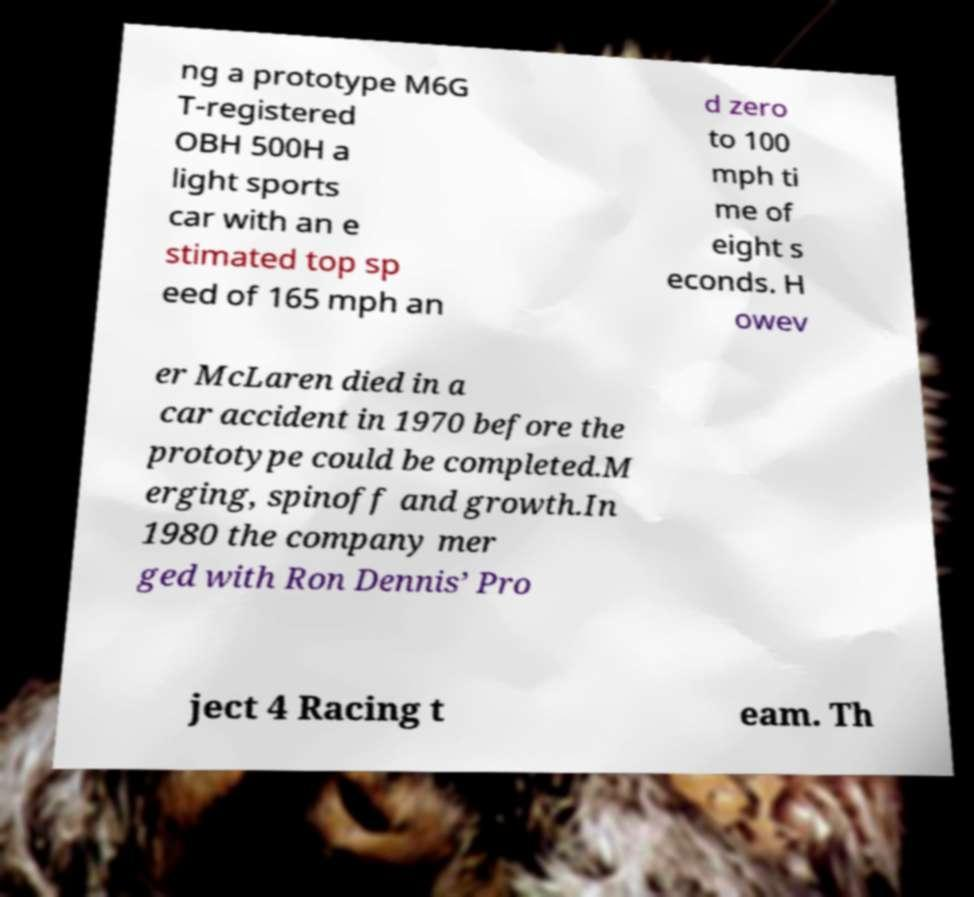Could you extract and type out the text from this image? ng a prototype M6G T-registered OBH 500H a light sports car with an e stimated top sp eed of 165 mph an d zero to 100 mph ti me of eight s econds. H owev er McLaren died in a car accident in 1970 before the prototype could be completed.M erging, spinoff and growth.In 1980 the company mer ged with Ron Dennis’ Pro ject 4 Racing t eam. Th 